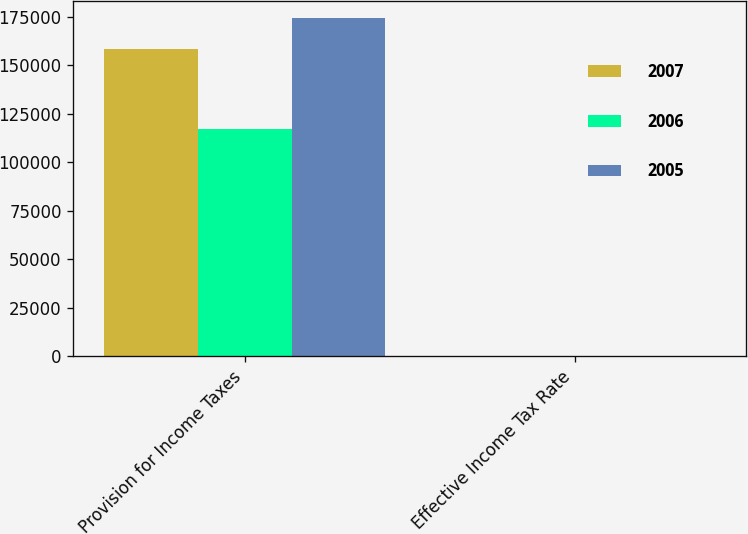Convert chart to OTSL. <chart><loc_0><loc_0><loc_500><loc_500><stacked_bar_chart><ecel><fcel>Provision for Income Taxes<fcel>Effective Income Tax Rate<nl><fcel>2007<fcel>158444<fcel>24<nl><fcel>2006<fcel>117418<fcel>18.5<nl><fcel>2005<fcel>174320<fcel>31.7<nl></chart> 